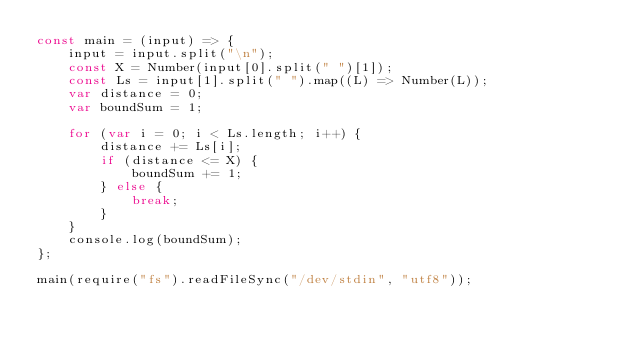<code> <loc_0><loc_0><loc_500><loc_500><_JavaScript_>const main = (input) => {
    input = input.split("\n");
    const X = Number(input[0].split(" ")[1]);
    const Ls = input[1].split(" ").map((L) => Number(L));
    var distance = 0;
    var boundSum = 1;

    for (var i = 0; i < Ls.length; i++) {
        distance += Ls[i];
        if (distance <= X) {
            boundSum += 1;
        } else {
            break;
        }
    }
    console.log(boundSum);
};

main(require("fs").readFileSync("/dev/stdin", "utf8"));</code> 